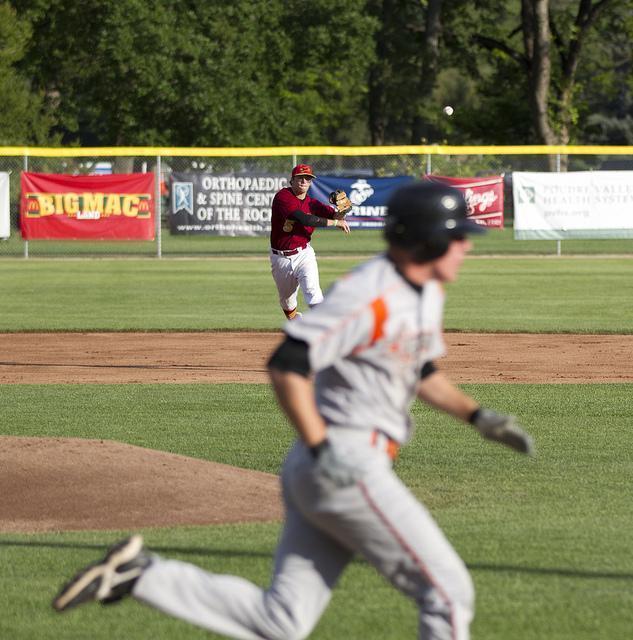Why is the player blurry?
Choose the right answer and clarify with the format: 'Answer: answer
Rationale: rationale.'
Options: Moving fast, bad film, broken camera, shaky photographer. Answer: moving fast.
Rationale: The stationary objects in the background are not blurry, so there is nothing wrong with the photographer, camera, or film. 